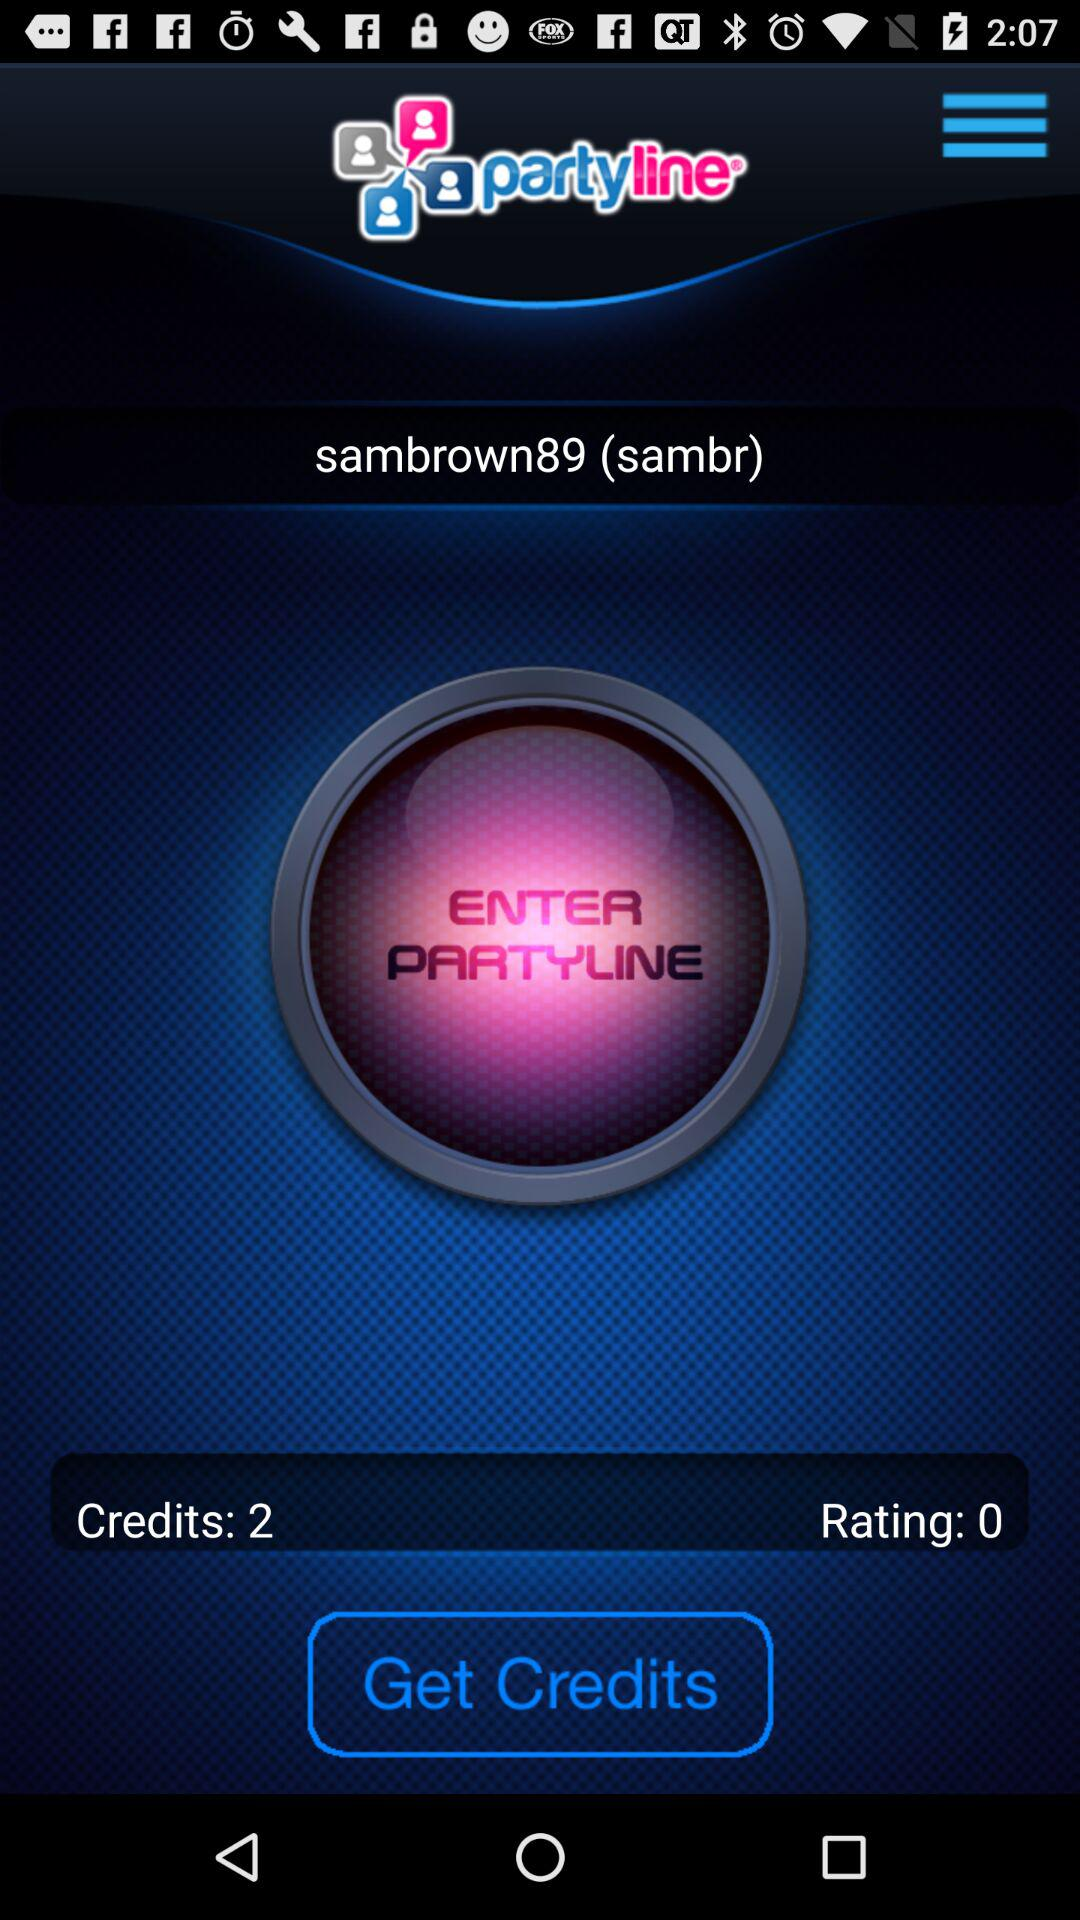How many more credits do I need to get to 5?
Answer the question using a single word or phrase. 3 